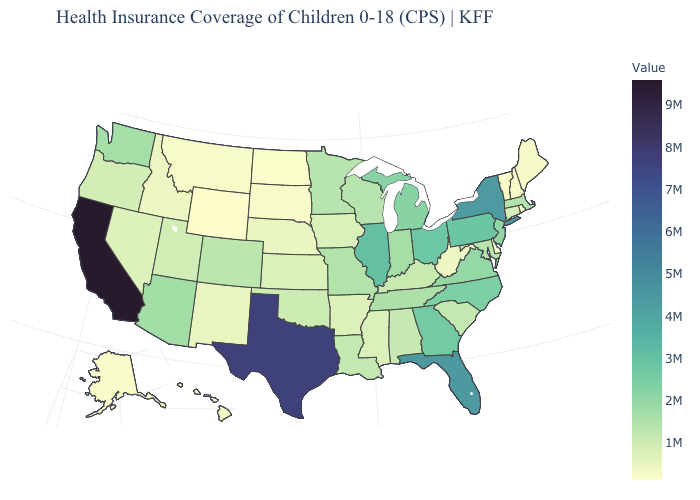Does Illinois have the highest value in the MidWest?
Concise answer only. Yes. Among the states that border Massachusetts , does Connecticut have the lowest value?
Quick response, please. No. Does the map have missing data?
Be succinct. No. Does Colorado have a lower value than Montana?
Be succinct. No. Is the legend a continuous bar?
Quick response, please. Yes. 